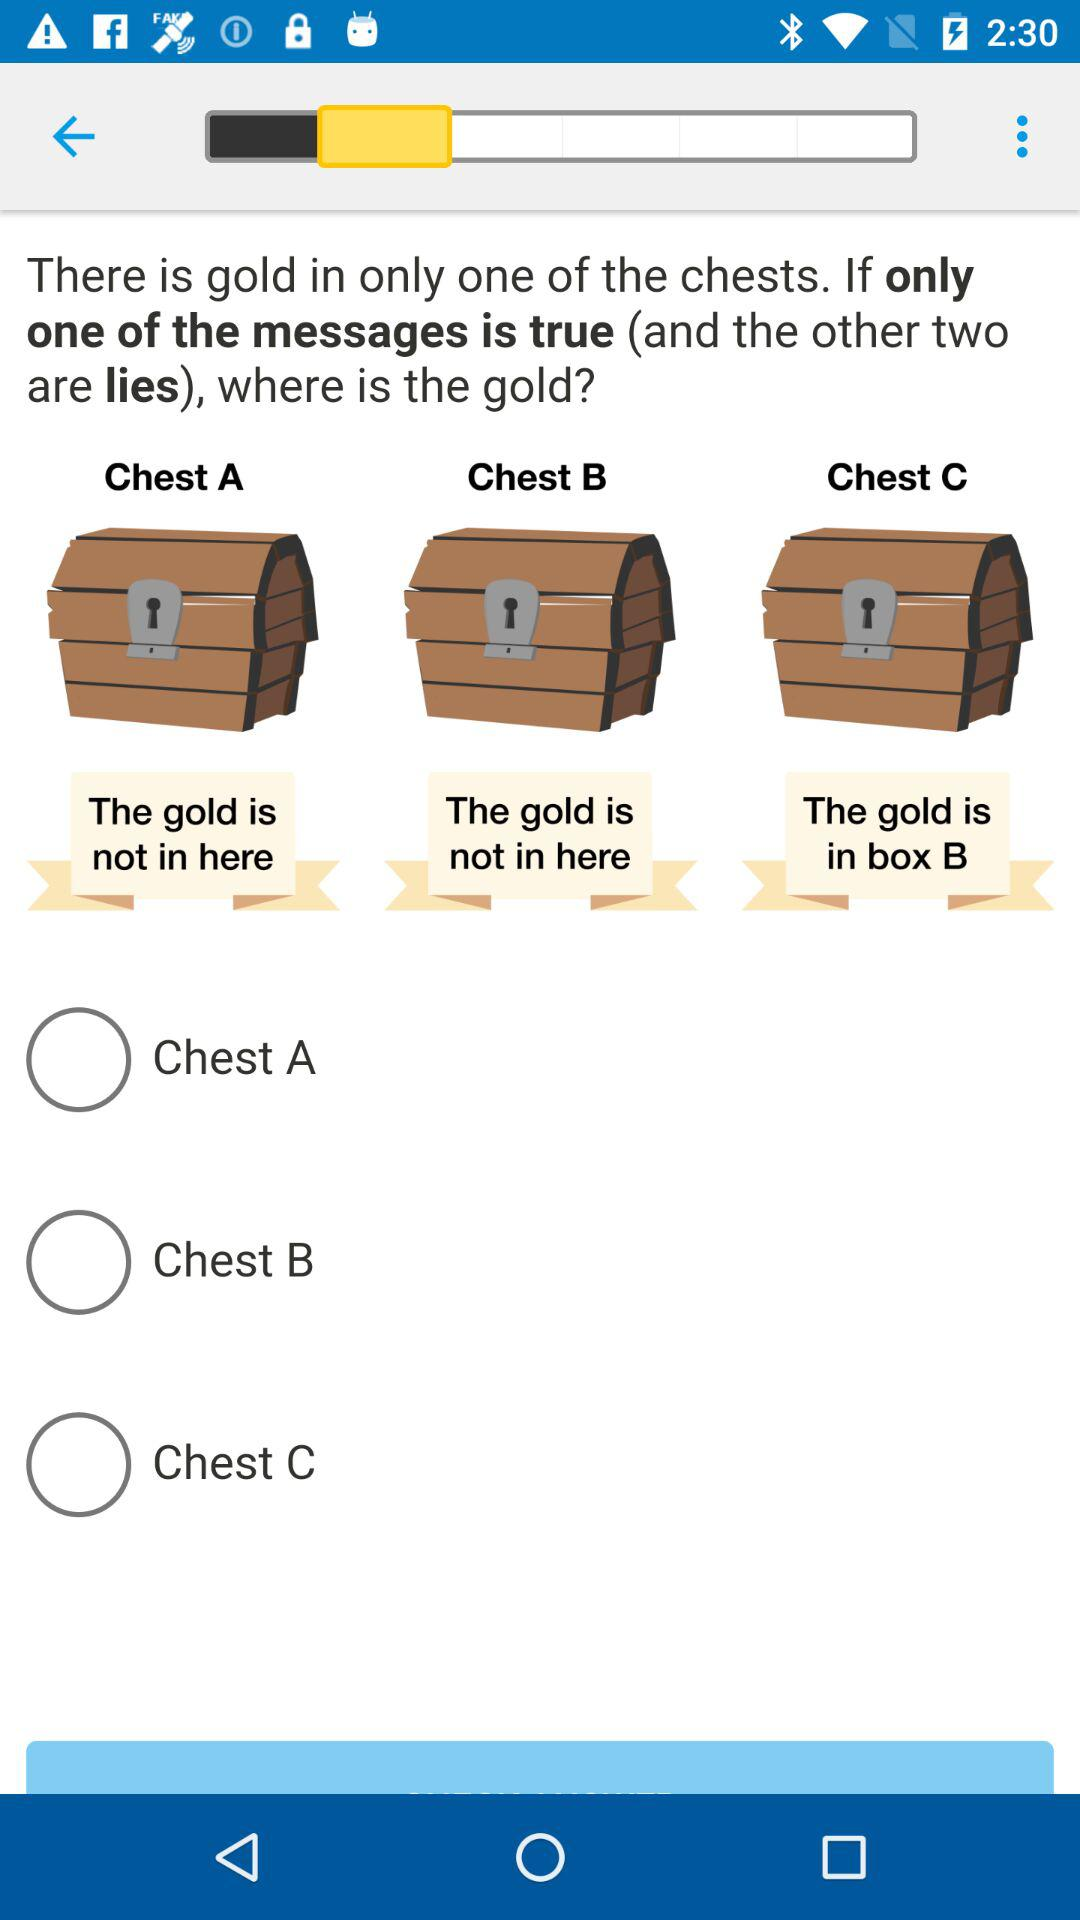Which chest has the text 'The gold is in box B'?
Answer the question using a single word or phrase. Chest C 